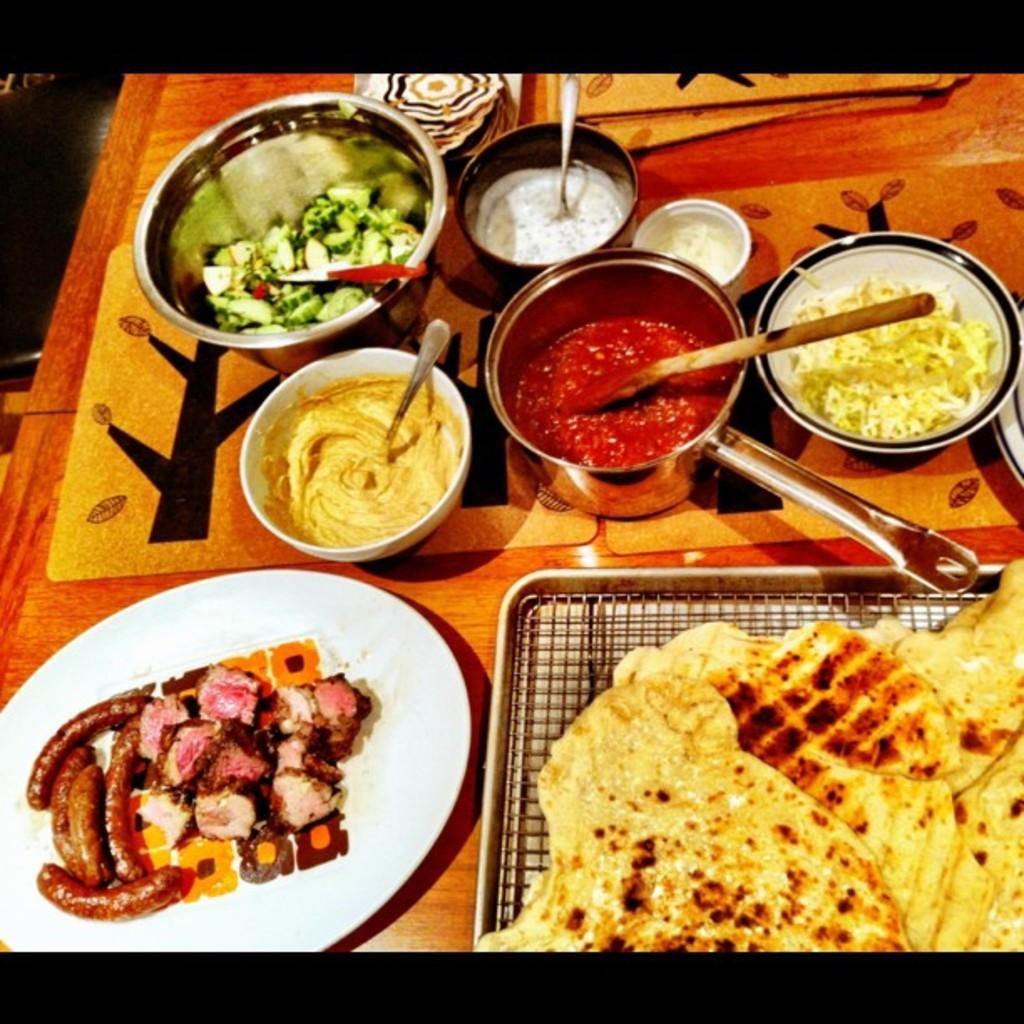What type of containers hold the food in the image? There are bowls and plates in the image that hold the food. What utensils are visible in the image? Spoons are visible in the image. Can you describe the food that is on the plates? Unfortunately, the specific type of food on the plates cannot be determined from the image. How many cows are visible in the image? There are no cows present in the image. What type of planes are flying in the background of the image? There is no background or planes visible in the image. 